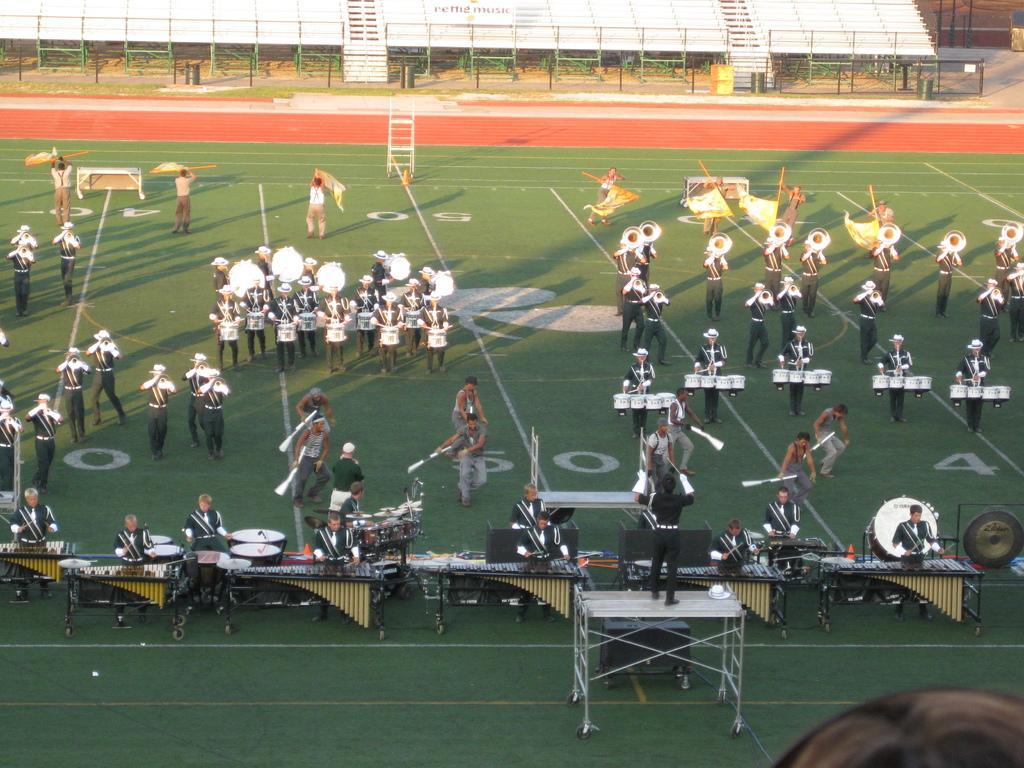Please provide a concise description of this image. Group of people performing different musical actions in the ground. 